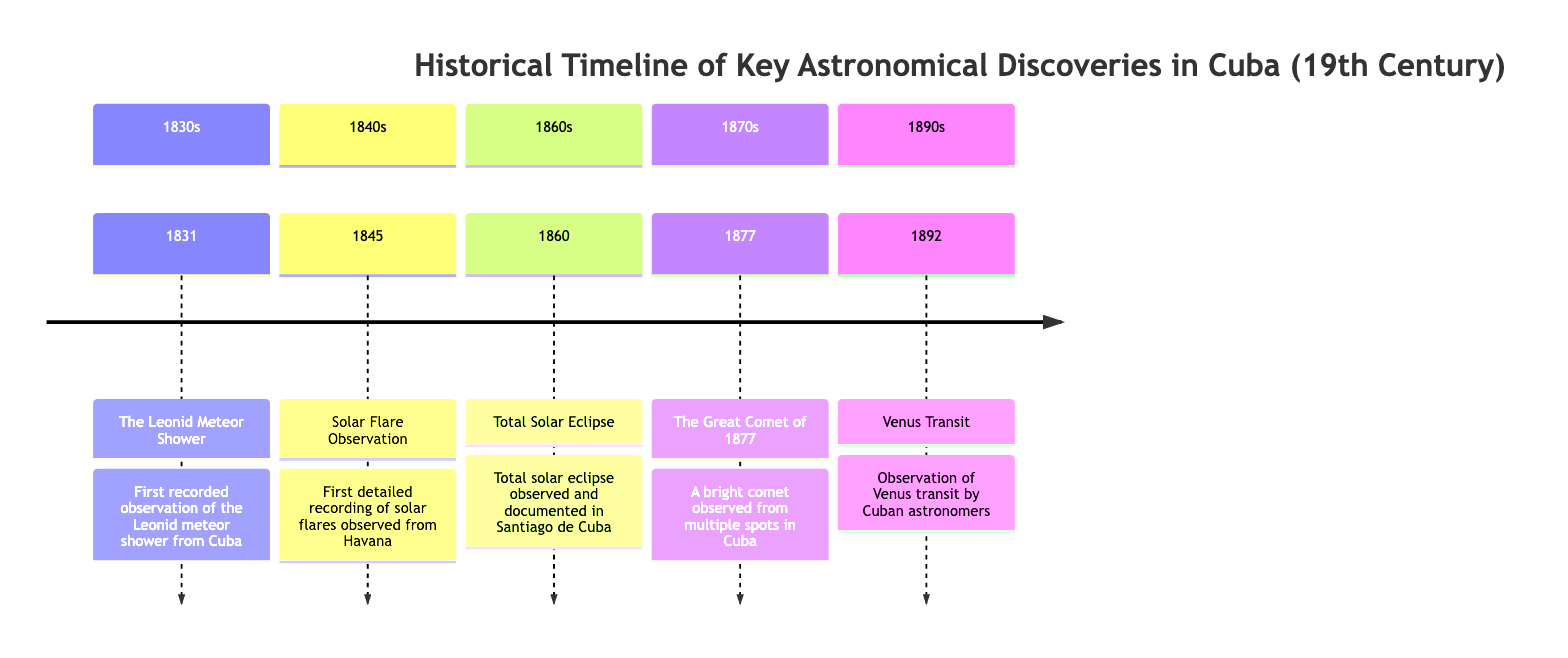What significant astronomical event was recorded in Cuba in 1831? The diagram indicates that the significant astronomical event recorded in Cuba in 1831 was the Leonid Meteor Shower. This is found in the section dedicated to the 1830s, highlighting its importance as the first recorded observation.
Answer: Leonid Meteor Shower What year did Cuban astronomers observe the transit of Venus? According to the diagram, the observation of the Venus transit by Cuban astronomers occurred in 1892, which is the only event listed in the 1890s section.
Answer: 1892 How many sections are documented in the timeline? By reviewing the diagram, it shows distinct sections labeled by decades starting from the 1830s to the 1890s. These include five sections: 1830s, 1840s, 1860s, 1870s, and 1890s. Therefore, the total number of sections is five.
Answer: 5 Which astronomical phenomenon was first observed from Havana in 1845? The diagram specifies that in 1845, the first detailed recording of solar flares was observed from Havana. This phenomenon is highlighted in the section for the 1840s, clearly indicating its significance.
Answer: Solar Flare Observation Which discovery occurred in the 1870s and involved a comet? The discovery involving a comet in the 1870s, as detailed in the diagram, is the Great Comet of 1877. It points out that this was a bright comet observed from multiple spots in Cuba.
Answer: The Great Comet of 1877 In what city was the total solar eclipse observed in 1860? The diagram indicates that the total solar eclipse observed in 1860 was documented specifically in Santiago de Cuba. This location is distinctly noted in the section for the 1860s, emphasizing where the observation took place.
Answer: Santiago de Cuba 